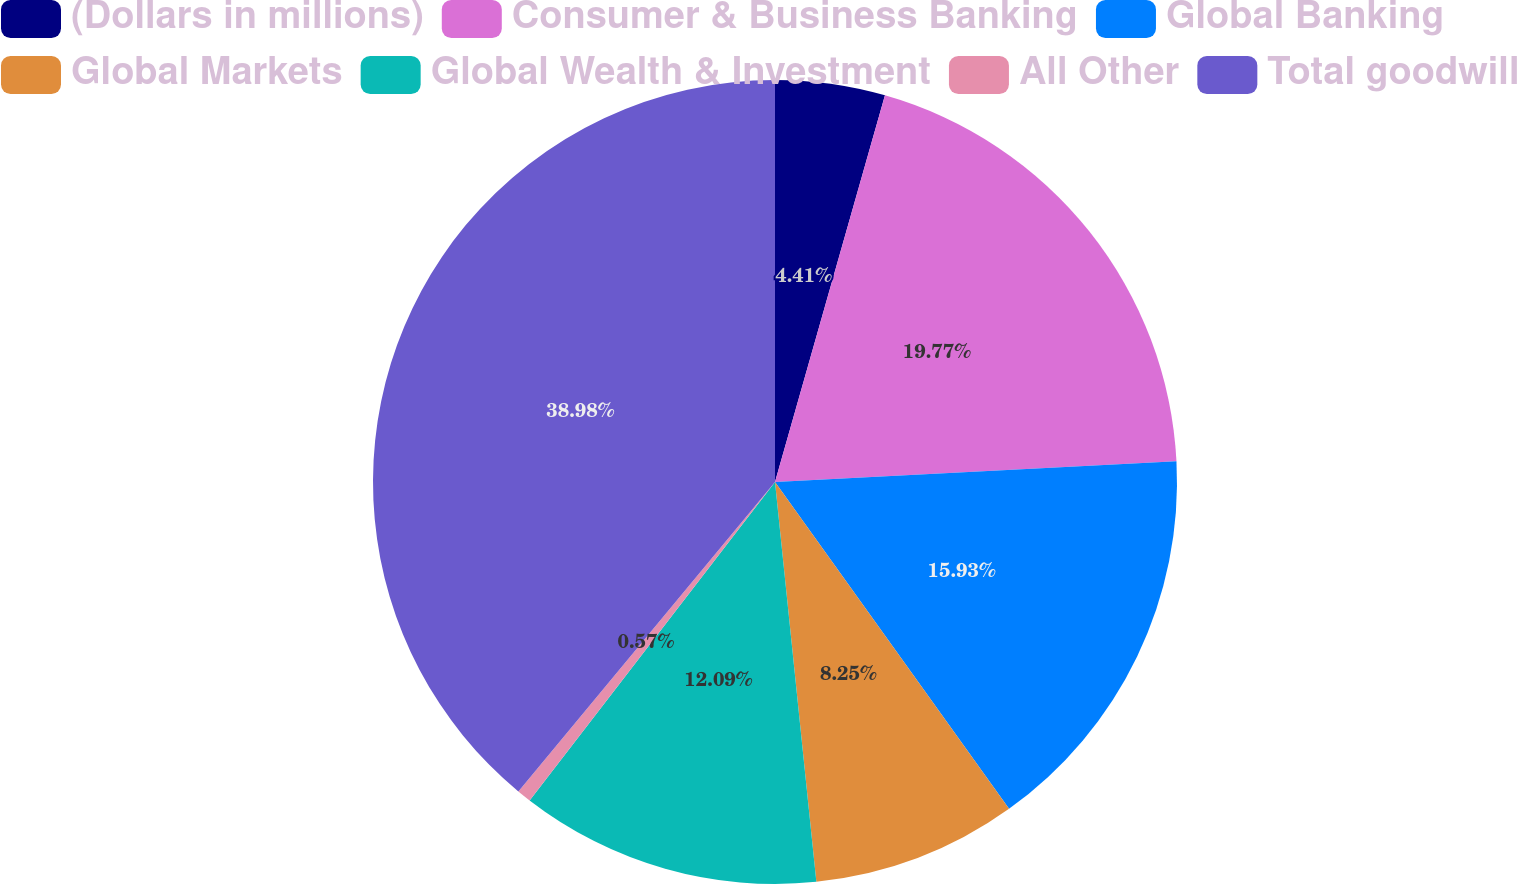Convert chart. <chart><loc_0><loc_0><loc_500><loc_500><pie_chart><fcel>(Dollars in millions)<fcel>Consumer & Business Banking<fcel>Global Banking<fcel>Global Markets<fcel>Global Wealth & Investment<fcel>All Other<fcel>Total goodwill<nl><fcel>4.41%<fcel>19.77%<fcel>15.93%<fcel>8.25%<fcel>12.09%<fcel>0.57%<fcel>38.98%<nl></chart> 